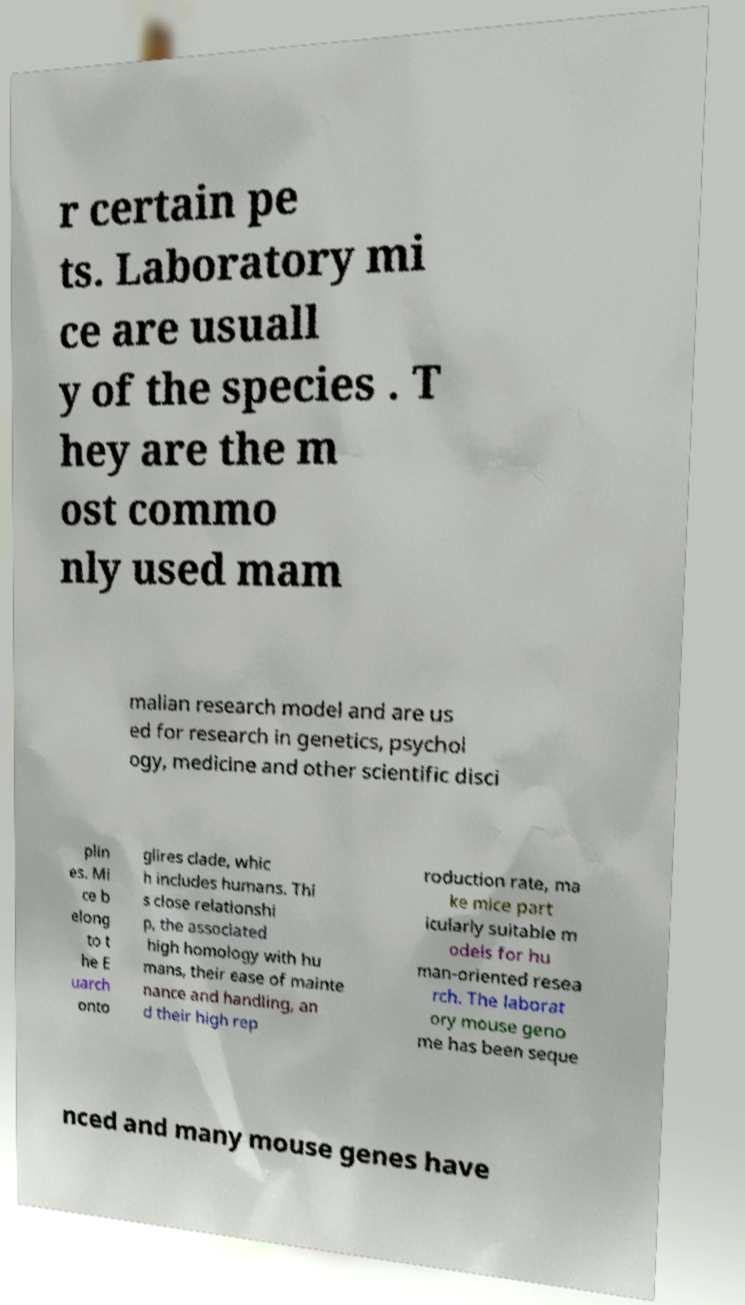Can you accurately transcribe the text from the provided image for me? r certain pe ts. Laboratory mi ce are usuall y of the species . T hey are the m ost commo nly used mam malian research model and are us ed for research in genetics, psychol ogy, medicine and other scientific disci plin es. Mi ce b elong to t he E uarch onto glires clade, whic h includes humans. Thi s close relationshi p, the associated high homology with hu mans, their ease of mainte nance and handling, an d their high rep roduction rate, ma ke mice part icularly suitable m odels for hu man-oriented resea rch. The laborat ory mouse geno me has been seque nced and many mouse genes have 